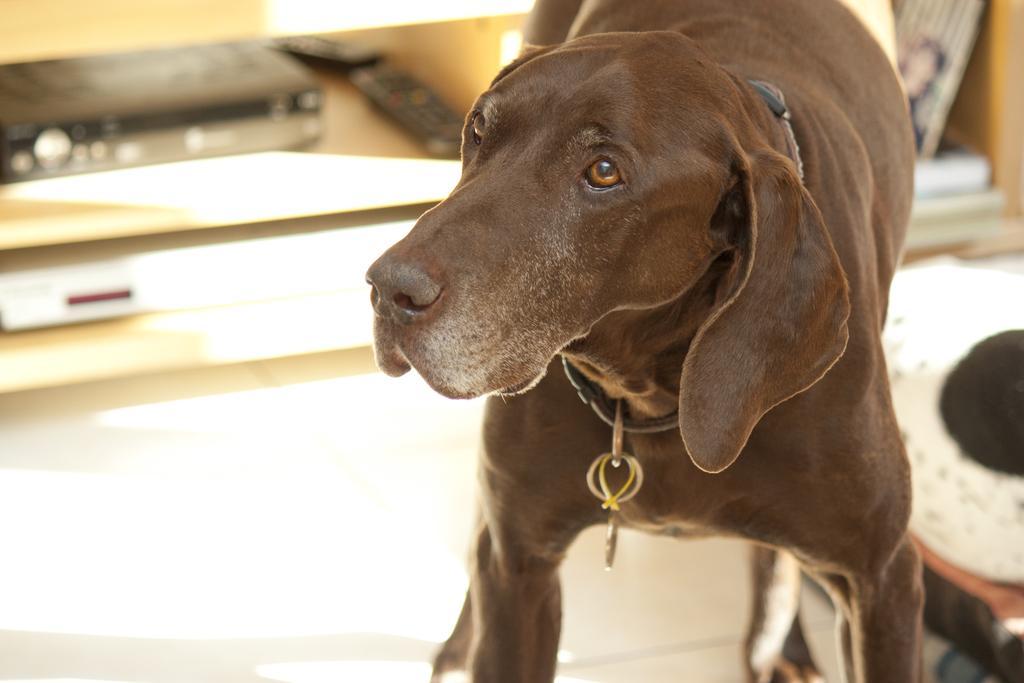How would you summarize this image in a sentence or two? In this picture I can observe a dog in the middle of the picture. This dog is in chocolate color. The background is blurred. 